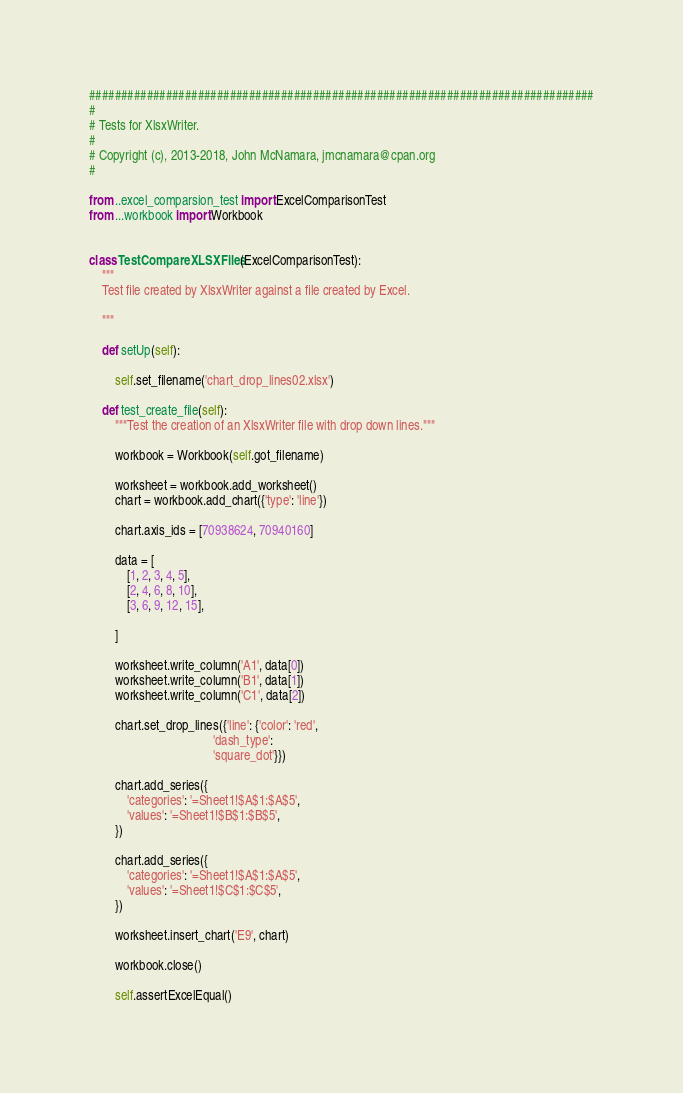<code> <loc_0><loc_0><loc_500><loc_500><_Python_>###############################################################################
#
# Tests for XlsxWriter.
#
# Copyright (c), 2013-2018, John McNamara, jmcnamara@cpan.org
#

from ..excel_comparsion_test import ExcelComparisonTest
from ...workbook import Workbook


class TestCompareXLSXFiles(ExcelComparisonTest):
    """
    Test file created by XlsxWriter against a file created by Excel.

    """

    def setUp(self):

        self.set_filename('chart_drop_lines02.xlsx')

    def test_create_file(self):
        """Test the creation of an XlsxWriter file with drop down lines."""

        workbook = Workbook(self.got_filename)

        worksheet = workbook.add_worksheet()
        chart = workbook.add_chart({'type': 'line'})

        chart.axis_ids = [70938624, 70940160]

        data = [
            [1, 2, 3, 4, 5],
            [2, 4, 6, 8, 10],
            [3, 6, 9, 12, 15],

        ]

        worksheet.write_column('A1', data[0])
        worksheet.write_column('B1', data[1])
        worksheet.write_column('C1', data[2])

        chart.set_drop_lines({'line': {'color': 'red',
                                       'dash_type':
                                       'square_dot'}})

        chart.add_series({
            'categories': '=Sheet1!$A$1:$A$5',
            'values': '=Sheet1!$B$1:$B$5',
        })

        chart.add_series({
            'categories': '=Sheet1!$A$1:$A$5',
            'values': '=Sheet1!$C$1:$C$5',
        })

        worksheet.insert_chart('E9', chart)

        workbook.close()

        self.assertExcelEqual()
</code> 